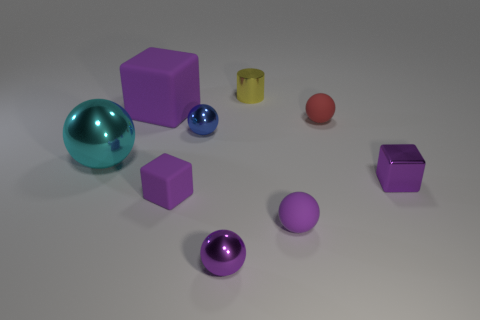There is a matte cube that is the same color as the large matte object; what is its size?
Ensure brevity in your answer.  Small. What is the shape of the large thing that is the same color as the metallic cube?
Provide a short and direct response. Cube. There is a tiny matte cube; is it the same color as the metallic thing on the right side of the tiny yellow cylinder?
Make the answer very short. Yes. There is a rubber block to the right of the big purple thing; does it have the same color as the shiny cube?
Keep it short and to the point. Yes. Is the material of the red sphere the same as the large purple cube?
Your answer should be very brief. Yes. What color is the matte object that is both in front of the red thing and to the right of the blue object?
Ensure brevity in your answer.  Purple. Are there any purple objects of the same size as the red matte sphere?
Provide a succinct answer. Yes. There is a purple metallic object behind the tiny purple sphere to the left of the tiny purple rubber sphere; how big is it?
Your response must be concise. Small. Are there fewer purple objects that are to the right of the tiny matte block than cyan objects?
Your answer should be very brief. No. Do the metal cube and the big matte thing have the same color?
Keep it short and to the point. Yes. 